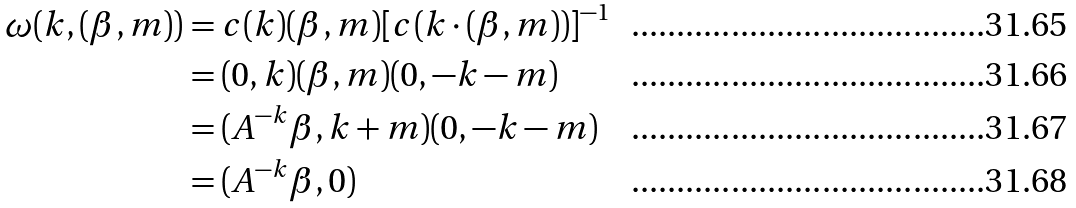Convert formula to latex. <formula><loc_0><loc_0><loc_500><loc_500>\omega ( k , ( \beta , m ) ) & = c ( k ) ( \beta , m ) [ c ( k \cdot ( \beta , m ) ) ] ^ { - 1 } \\ & = ( 0 , k ) ( \beta , m ) ( 0 , - k - m ) \\ & = ( A ^ { - k } \beta , k + m ) ( 0 , - k - m ) \\ & = ( A ^ { - k } \beta , 0 )</formula> 